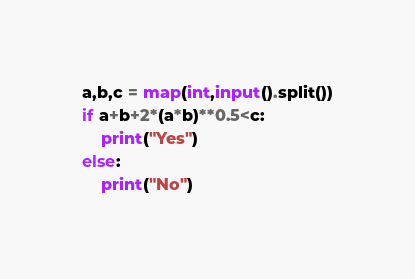<code> <loc_0><loc_0><loc_500><loc_500><_Python_>a,b,c = map(int,input().split())
if a+b+2*(a*b)**0.5<c:
    print("Yes")
else:
    print("No")</code> 